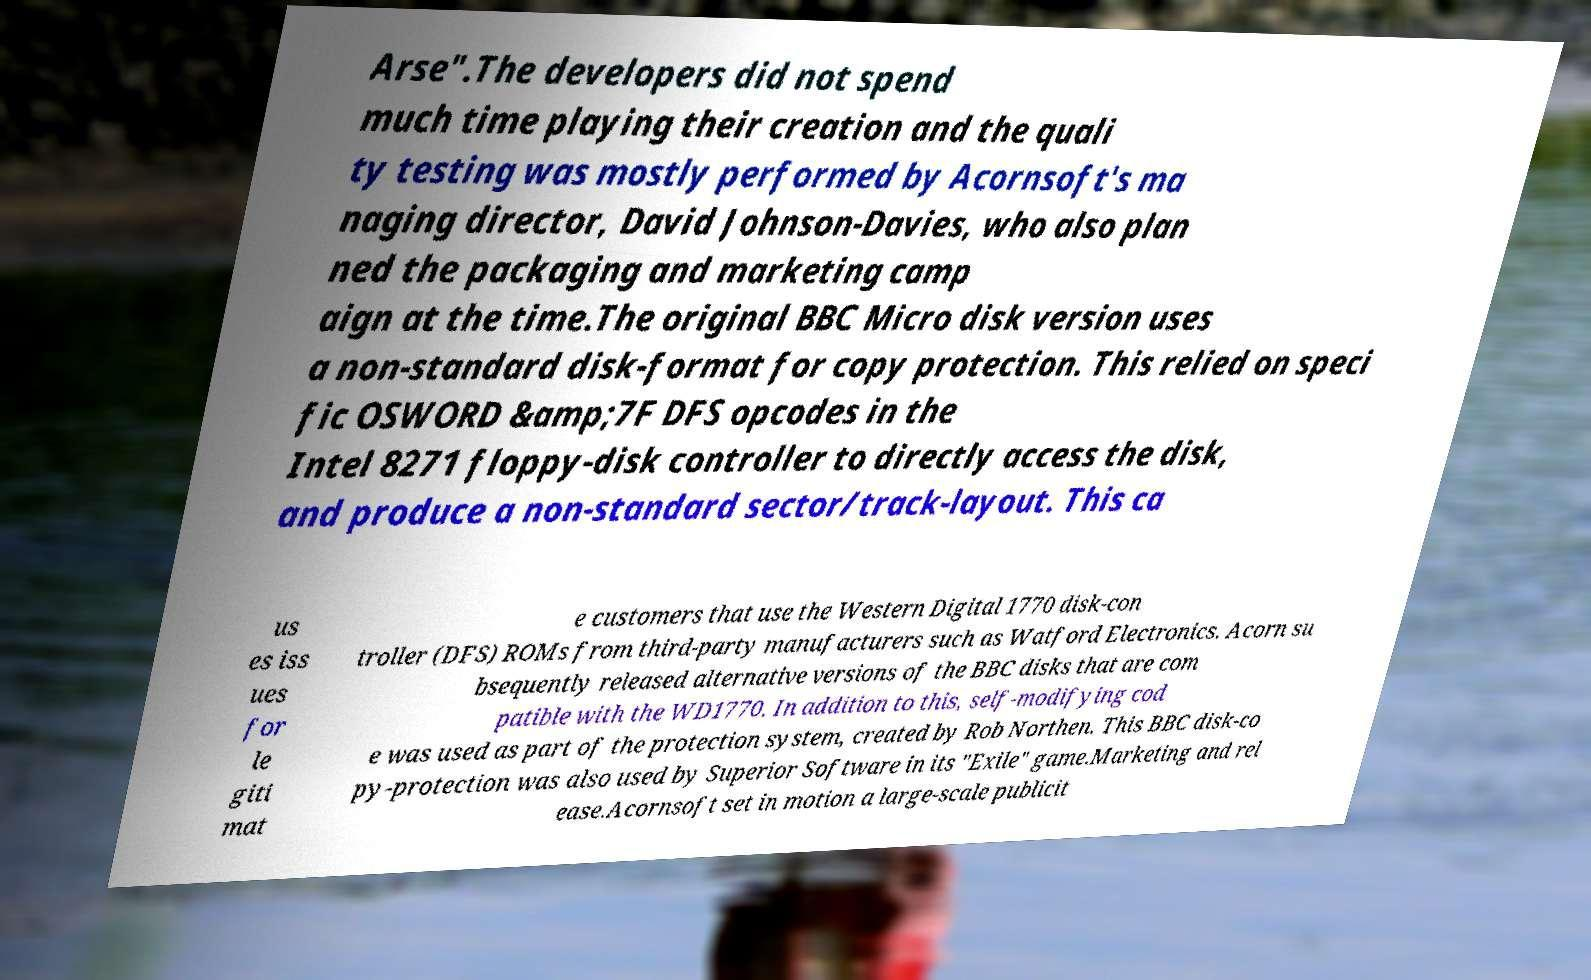For documentation purposes, I need the text within this image transcribed. Could you provide that? Arse".The developers did not spend much time playing their creation and the quali ty testing was mostly performed by Acornsoft's ma naging director, David Johnson-Davies, who also plan ned the packaging and marketing camp aign at the time.The original BBC Micro disk version uses a non-standard disk-format for copy protection. This relied on speci fic OSWORD &amp;7F DFS opcodes in the Intel 8271 floppy-disk controller to directly access the disk, and produce a non-standard sector/track-layout. This ca us es iss ues for le giti mat e customers that use the Western Digital 1770 disk-con troller (DFS) ROMs from third-party manufacturers such as Watford Electronics. Acorn su bsequently released alternative versions of the BBC disks that are com patible with the WD1770. In addition to this, self-modifying cod e was used as part of the protection system, created by Rob Northen. This BBC disk-co py-protection was also used by Superior Software in its "Exile" game.Marketing and rel ease.Acornsoft set in motion a large-scale publicit 